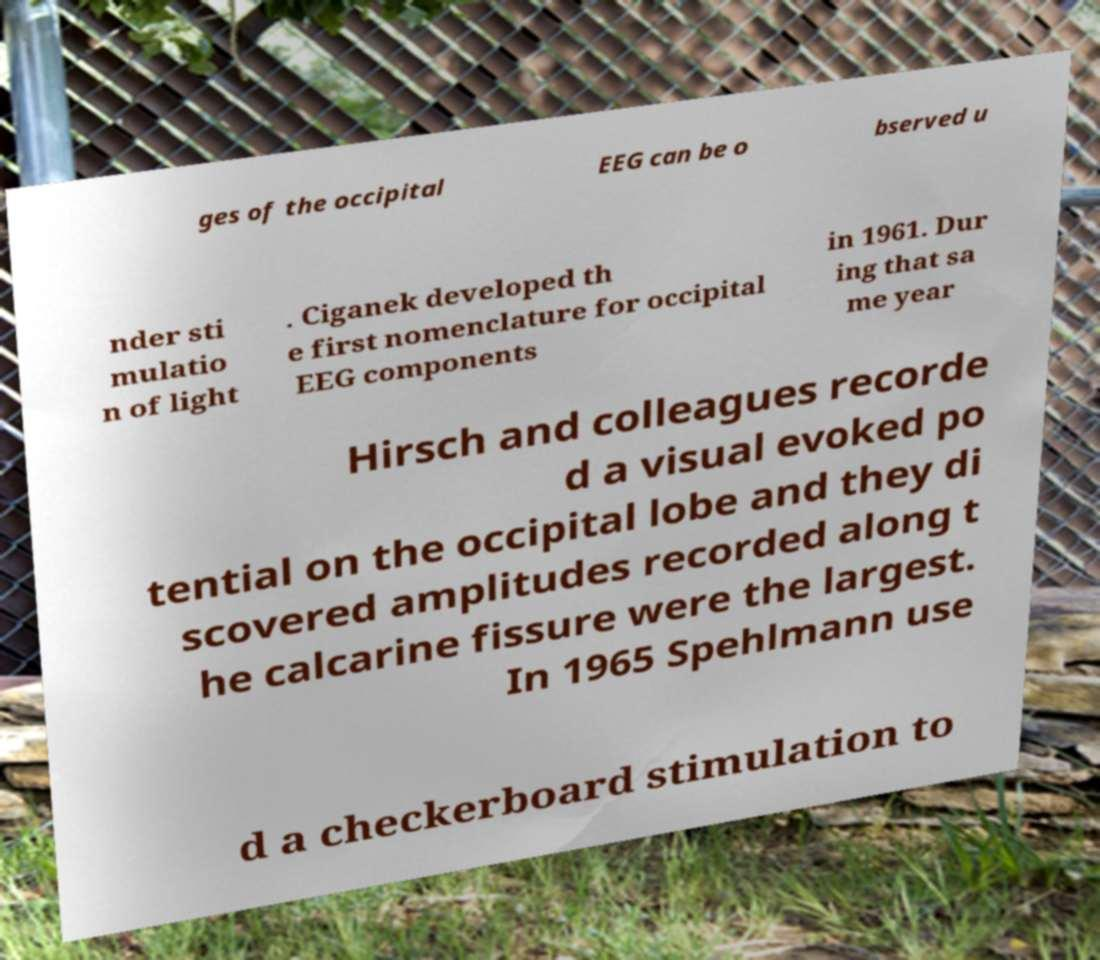Can you read and provide the text displayed in the image?This photo seems to have some interesting text. Can you extract and type it out for me? ges of the occipital EEG can be o bserved u nder sti mulatio n of light . Ciganek developed th e first nomenclature for occipital EEG components in 1961. Dur ing that sa me year Hirsch and colleagues recorde d a visual evoked po tential on the occipital lobe and they di scovered amplitudes recorded along t he calcarine fissure were the largest. In 1965 Spehlmann use d a checkerboard stimulation to 